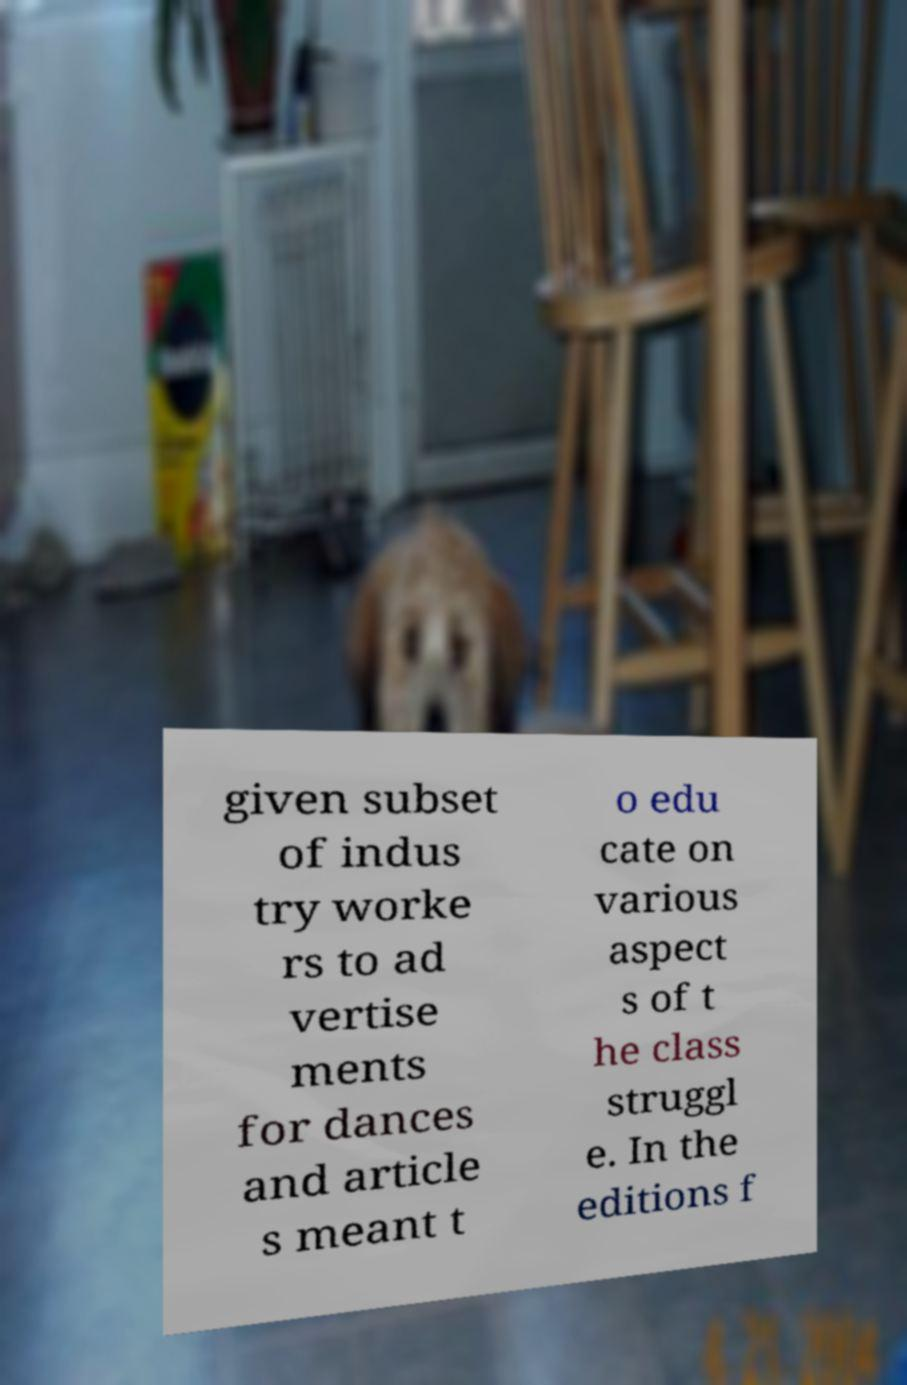There's text embedded in this image that I need extracted. Can you transcribe it verbatim? given subset of indus try worke rs to ad vertise ments for dances and article s meant t o edu cate on various aspect s of t he class struggl e. In the editions f 